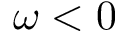Convert formula to latex. <formula><loc_0><loc_0><loc_500><loc_500>\omega < 0</formula> 